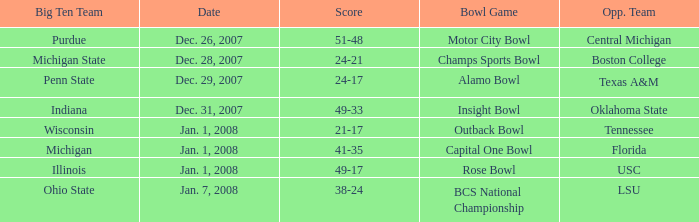Who was the opposing team in the game with a score of 21-17? Tennessee. 